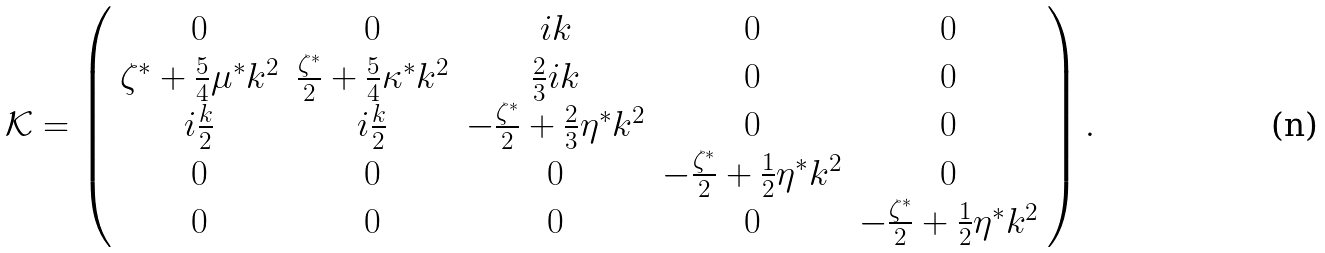<formula> <loc_0><loc_0><loc_500><loc_500>\mathcal { K } = \left ( \begin{array} { c c c c c } 0 & 0 & i k & 0 & 0 \\ \zeta ^ { \ast } + \frac { 5 } { 4 } \mu ^ { \ast } k ^ { 2 } & \frac { \zeta ^ { \ast } } { 2 } + \frac { 5 } { 4 } \kappa ^ { \ast } k ^ { 2 } & \frac { 2 } { 3 } i k & 0 & 0 \\ i \frac { k } { 2 } & i \frac { k } { 2 } & - \frac { \zeta ^ { \ast } } { 2 } + \frac { 2 } { 3 } \eta ^ { \ast } k ^ { 2 } & 0 & 0 \\ 0 & 0 & 0 & - \frac { \zeta ^ { \ast } } { 2 } + \frac { 1 } { 2 } \eta ^ { \ast } k ^ { 2 } & 0 \\ 0 & 0 & 0 & 0 & - \frac { \zeta ^ { \ast } } { 2 } + \frac { 1 } { 2 } \eta ^ { \ast } k ^ { 2 } \end{array} \right ) .</formula> 